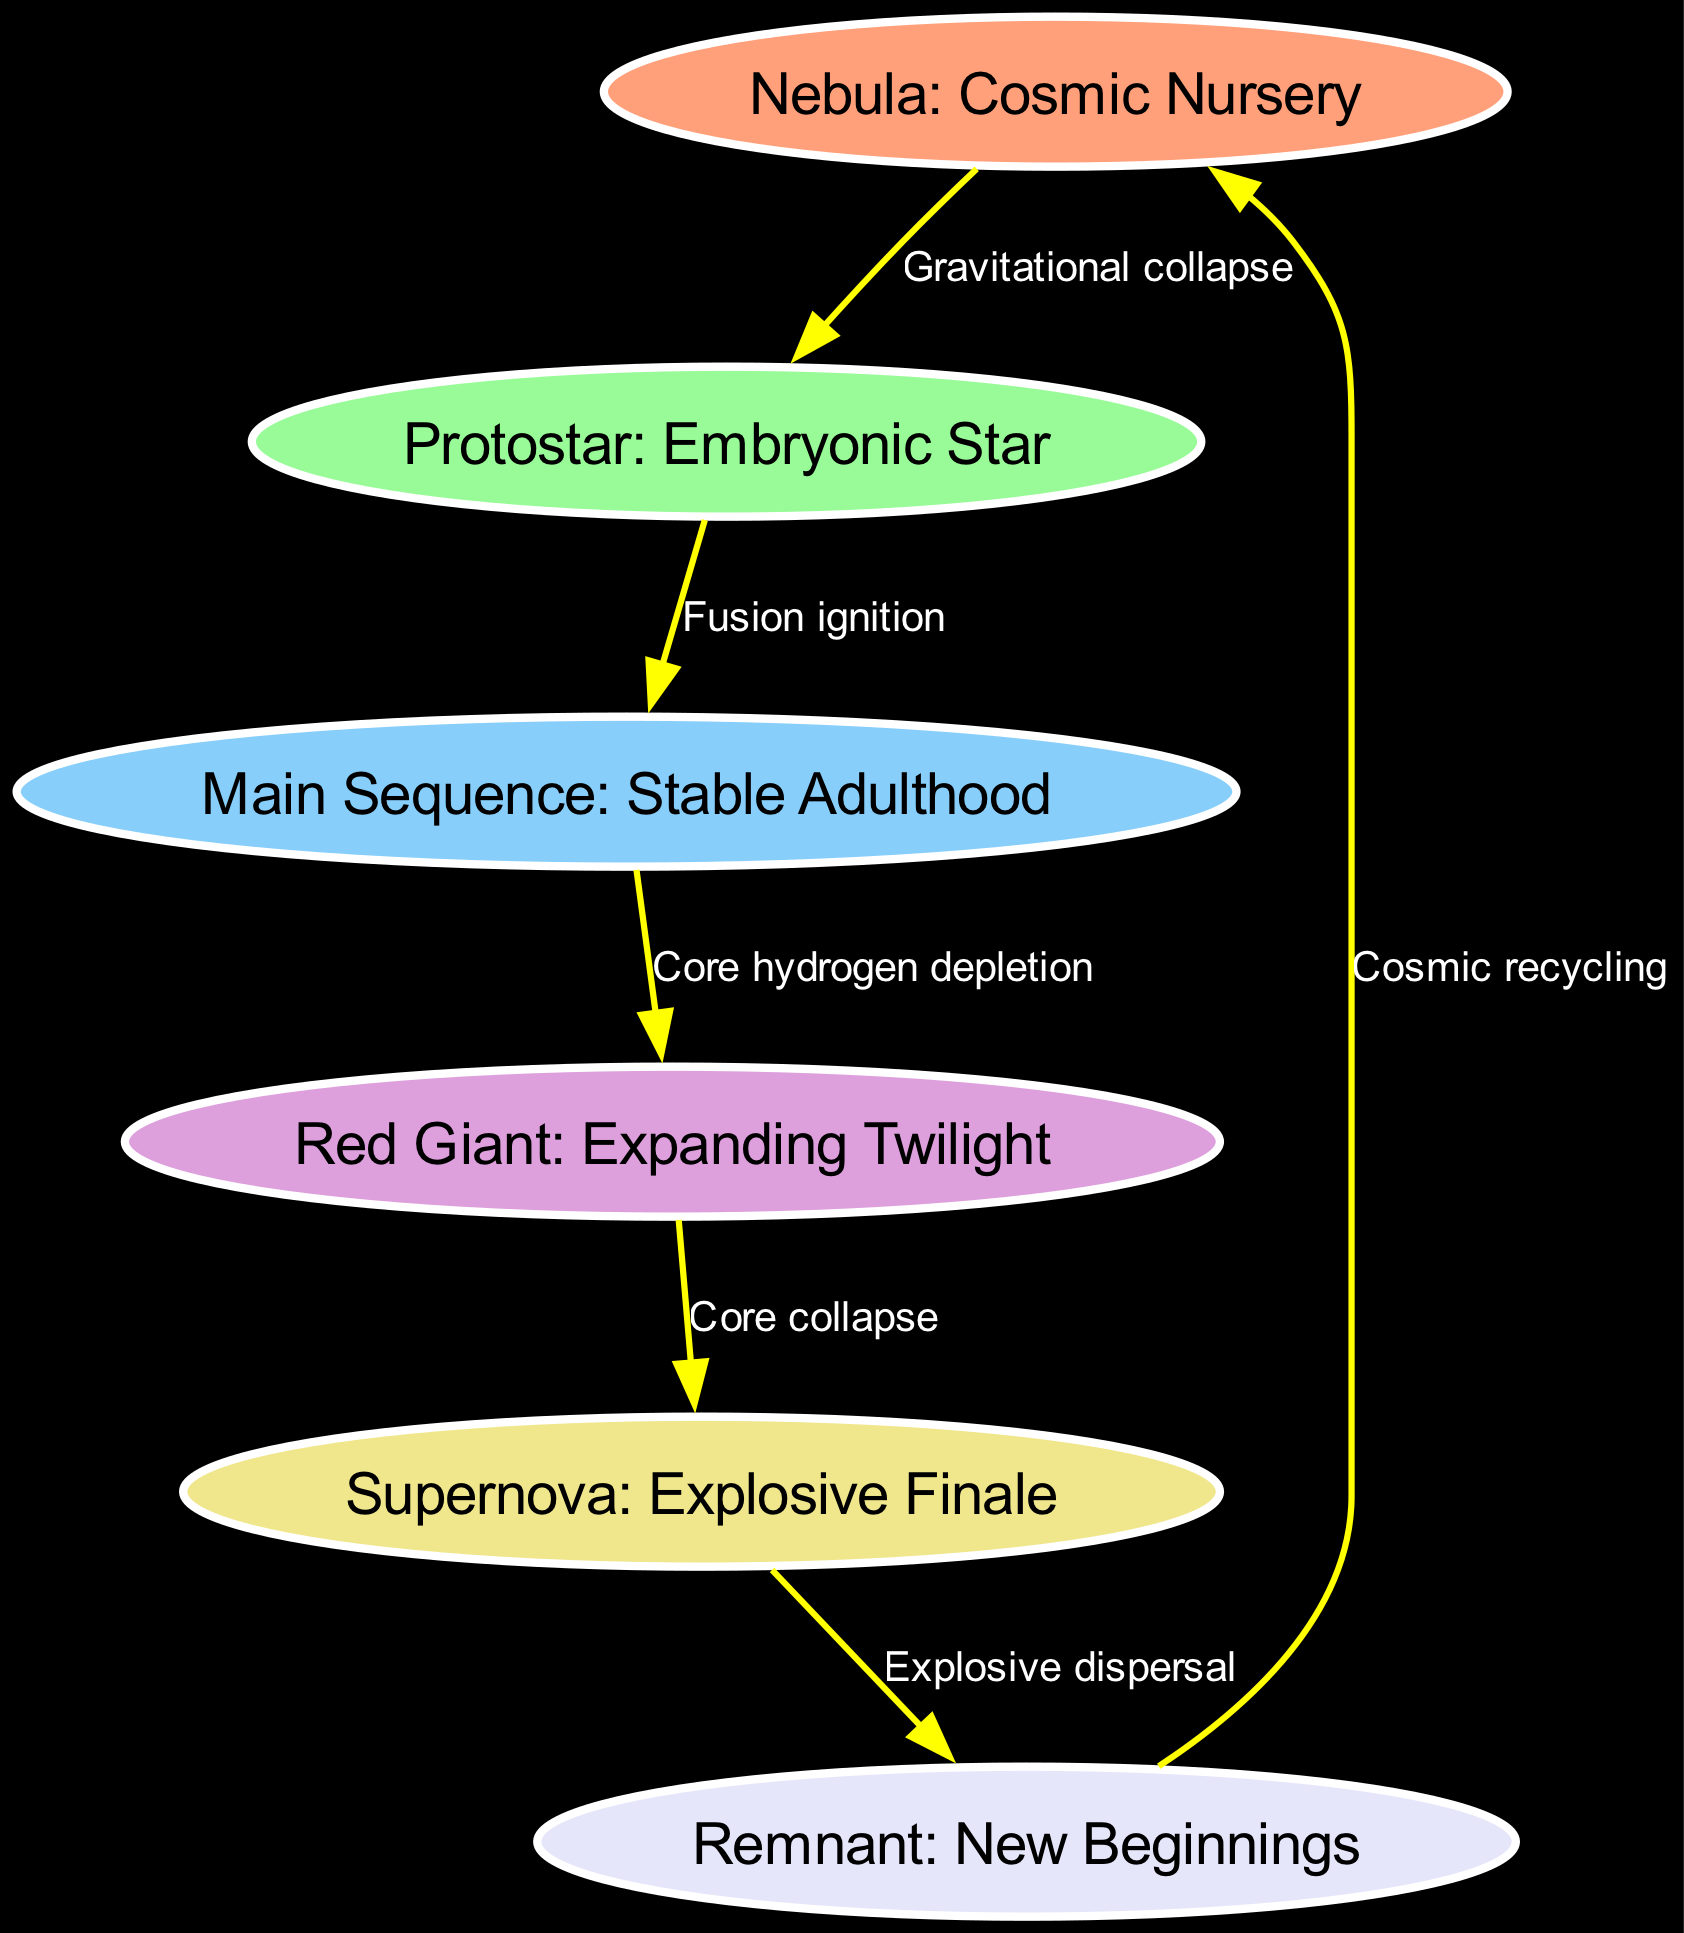What is the first stage of a star's life cycle? The diagram indicates "Nebula: Cosmic Nursery" as the first node in the life cycle of a star, representing the initial stage where stars are formed.
Answer: Nebula: Cosmic Nursery How many stages are represented in the diagram? By counting the nodes listed in the diagram, we find a total of six stages: Nebula, Protostar, Main Sequence, Red Giant, Supernova, and Remnant.
Answer: 6 What process leads from Protostar to Main Sequence? The edge labeled "Fusion ignition" connects the Protostar to the Main Sequence, indicating that this process is what enables the transition between these two stages.
Answer: Fusion ignition Which stage follows the Red Giant? The connection from the Red Giant node to the Supernova node shows that the supernova stage comes directly after the red giant stage in the stellar evolution process.
Answer: Supernova: Explosive Finale What is the final outcome after a Supernova? According to the diagram, the edge labeled "Explosive dispersal" leads from Supernova to Remnant, which signifies that the result of a supernova is the formation of a remnant.
Answer: Remnant: New Beginnings In which stage does core hydrogen depletion occur? The edge showing "Core hydrogen depletion" clearly connects the Main Sequence to the Red Giant, meaning that this process occurs during the transition from main sequence to red giant.
Answer: Red Giant: Expanding Twilight What initiates the star formation process? The arrow labeled "Gravitational collapse" from the Nebula to the Protostar indicates this is the initial process that triggers the formation of a protostar from a nebula.
Answer: Gravitational collapse What describes the relationship between Remnant and Nebula? The edge labeled "Cosmic recycling" indicates a cyclical relationship from Remnant back to Nebula, suggesting that remnants of stars contribute to the creation of new nebulae.
Answer: Cosmic recycling 